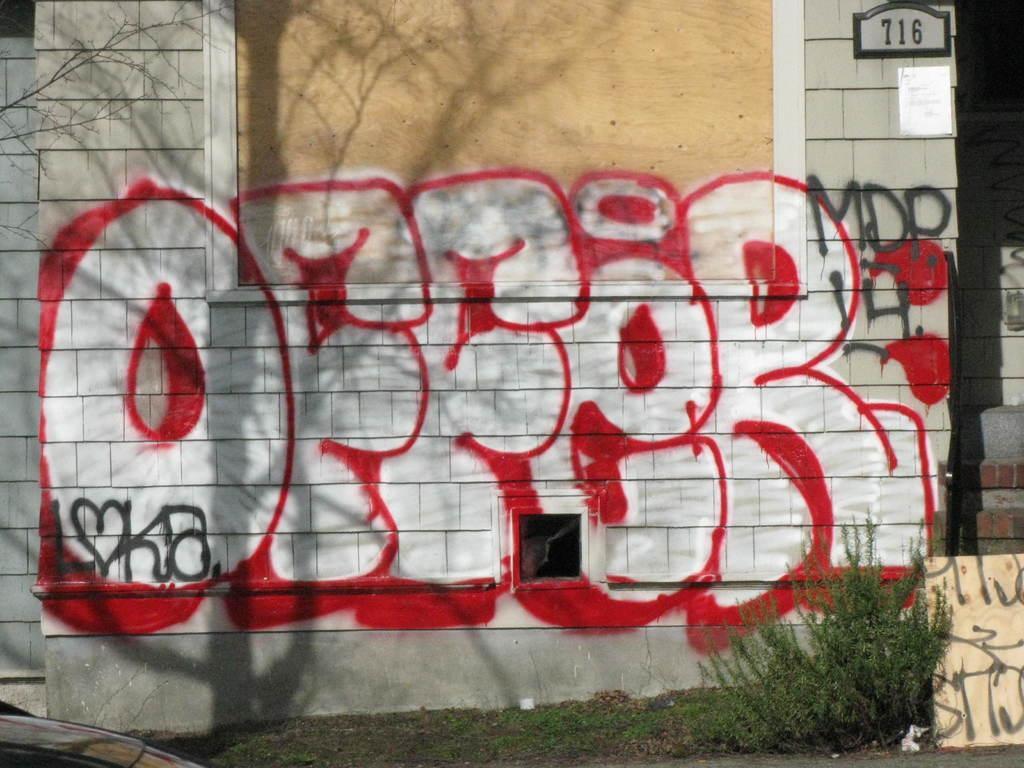Could you give a brief overview of what you see in this image? In the image there is a building with graffiti paint on it, in front of it there is a plant in a garden. 